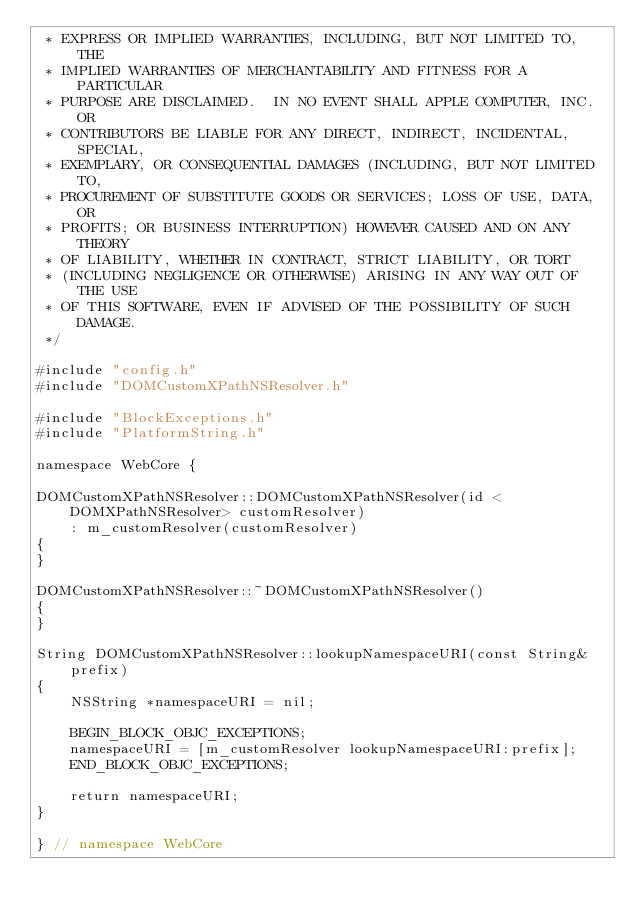<code> <loc_0><loc_0><loc_500><loc_500><_ObjectiveC_> * EXPRESS OR IMPLIED WARRANTIES, INCLUDING, BUT NOT LIMITED TO, THE
 * IMPLIED WARRANTIES OF MERCHANTABILITY AND FITNESS FOR A PARTICULAR
 * PURPOSE ARE DISCLAIMED.  IN NO EVENT SHALL APPLE COMPUTER, INC. OR
 * CONTRIBUTORS BE LIABLE FOR ANY DIRECT, INDIRECT, INCIDENTAL, SPECIAL,
 * EXEMPLARY, OR CONSEQUENTIAL DAMAGES (INCLUDING, BUT NOT LIMITED TO,
 * PROCUREMENT OF SUBSTITUTE GOODS OR SERVICES; LOSS OF USE, DATA, OR
 * PROFITS; OR BUSINESS INTERRUPTION) HOWEVER CAUSED AND ON ANY THEORY
 * OF LIABILITY, WHETHER IN CONTRACT, STRICT LIABILITY, OR TORT
 * (INCLUDING NEGLIGENCE OR OTHERWISE) ARISING IN ANY WAY OUT OF THE USE
 * OF THIS SOFTWARE, EVEN IF ADVISED OF THE POSSIBILITY OF SUCH DAMAGE. 
 */

#include "config.h"
#include "DOMCustomXPathNSResolver.h"

#include "BlockExceptions.h"
#include "PlatformString.h"

namespace WebCore {

DOMCustomXPathNSResolver::DOMCustomXPathNSResolver(id <DOMXPathNSResolver> customResolver)
    : m_customResolver(customResolver)
{
}

DOMCustomXPathNSResolver::~DOMCustomXPathNSResolver()
{
}

String DOMCustomXPathNSResolver::lookupNamespaceURI(const String& prefix)
{
    NSString *namespaceURI = nil;
    
    BEGIN_BLOCK_OBJC_EXCEPTIONS;
    namespaceURI = [m_customResolver lookupNamespaceURI:prefix];
    END_BLOCK_OBJC_EXCEPTIONS;
    
    return namespaceURI;
}

} // namespace WebCore
</code> 